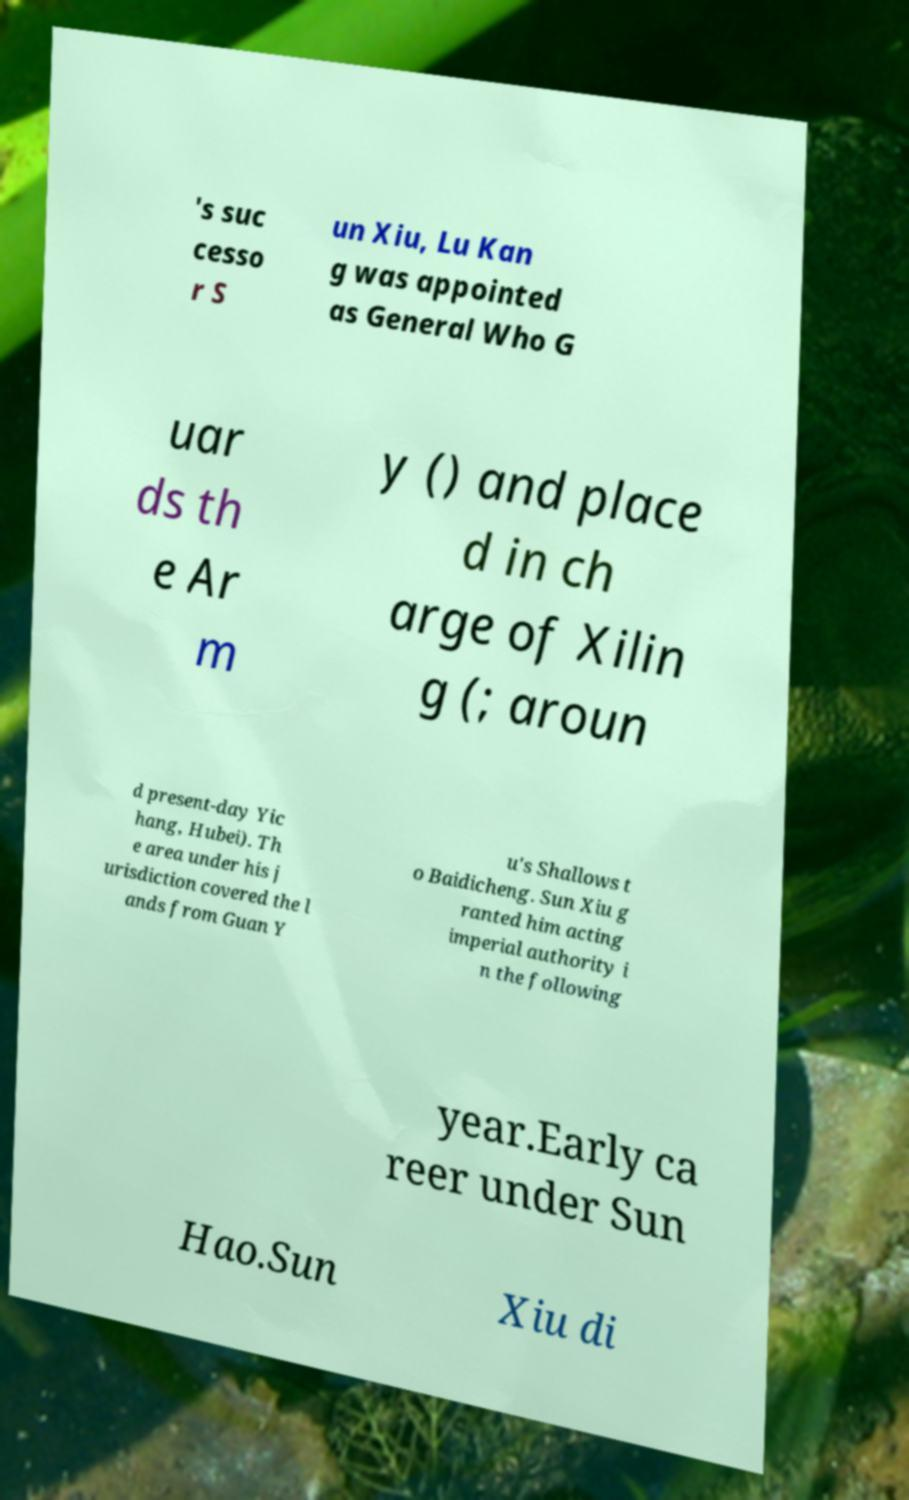I need the written content from this picture converted into text. Can you do that? 's suc cesso r S un Xiu, Lu Kan g was appointed as General Who G uar ds th e Ar m y () and place d in ch arge of Xilin g (; aroun d present-day Yic hang, Hubei). Th e area under his j urisdiction covered the l ands from Guan Y u's Shallows t o Baidicheng. Sun Xiu g ranted him acting imperial authority i n the following year.Early ca reer under Sun Hao.Sun Xiu di 